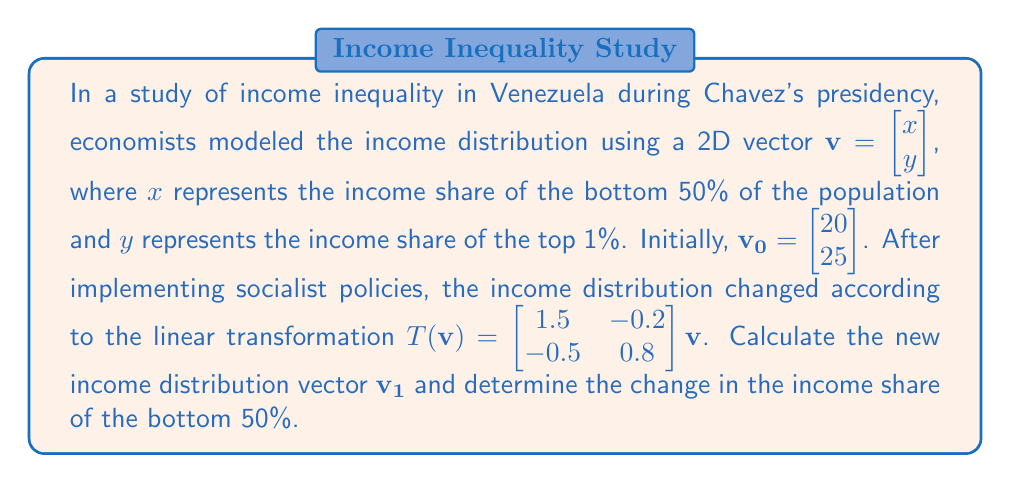Can you solve this math problem? To solve this problem, we need to apply the given linear transformation to the initial income distribution vector. Let's break it down step by step:

1) We are given the initial vector $\mathbf{v_0} = \begin{bmatrix} 20 \\ 25 \end{bmatrix}$ and the transformation matrix $T = \begin{bmatrix} 1.5 & -0.2 \\ -0.5 & 0.8 \end{bmatrix}$.

2) To find the new income distribution vector $\mathbf{v_1}$, we multiply $T$ by $\mathbf{v_0}$:

   $\mathbf{v_1} = T(\mathbf{v_0}) = \begin{bmatrix} 1.5 & -0.2 \\ -0.5 & 0.8 \end{bmatrix} \begin{bmatrix} 20 \\ 25 \end{bmatrix}$

3) Let's perform the matrix multiplication:

   $\begin{bmatrix} 1.5(20) + (-0.2)(25) \\ (-0.5)(20) + 0.8(25) \end{bmatrix} = \begin{bmatrix} 30 - 5 \\ -10 + 20 \end{bmatrix} = \begin{bmatrix} 25 \\ 10 \end{bmatrix}$

4) So, the new income distribution vector is $\mathbf{v_1} = \begin{bmatrix} 25 \\ 10 \end{bmatrix}$.

5) To determine the change in the income share of the bottom 50%, we compare the first component of $\mathbf{v_1}$ with the first component of $\mathbf{v_0}$:

   Change = $25 - 20 = 5$

Therefore, the income share of the bottom 50% increased by 5 percentage points.
Answer: The new income distribution vector is $\mathbf{v_1} = \begin{bmatrix} 25 \\ 10 \end{bmatrix}$, and the income share of the bottom 50% increased by 5 percentage points. 